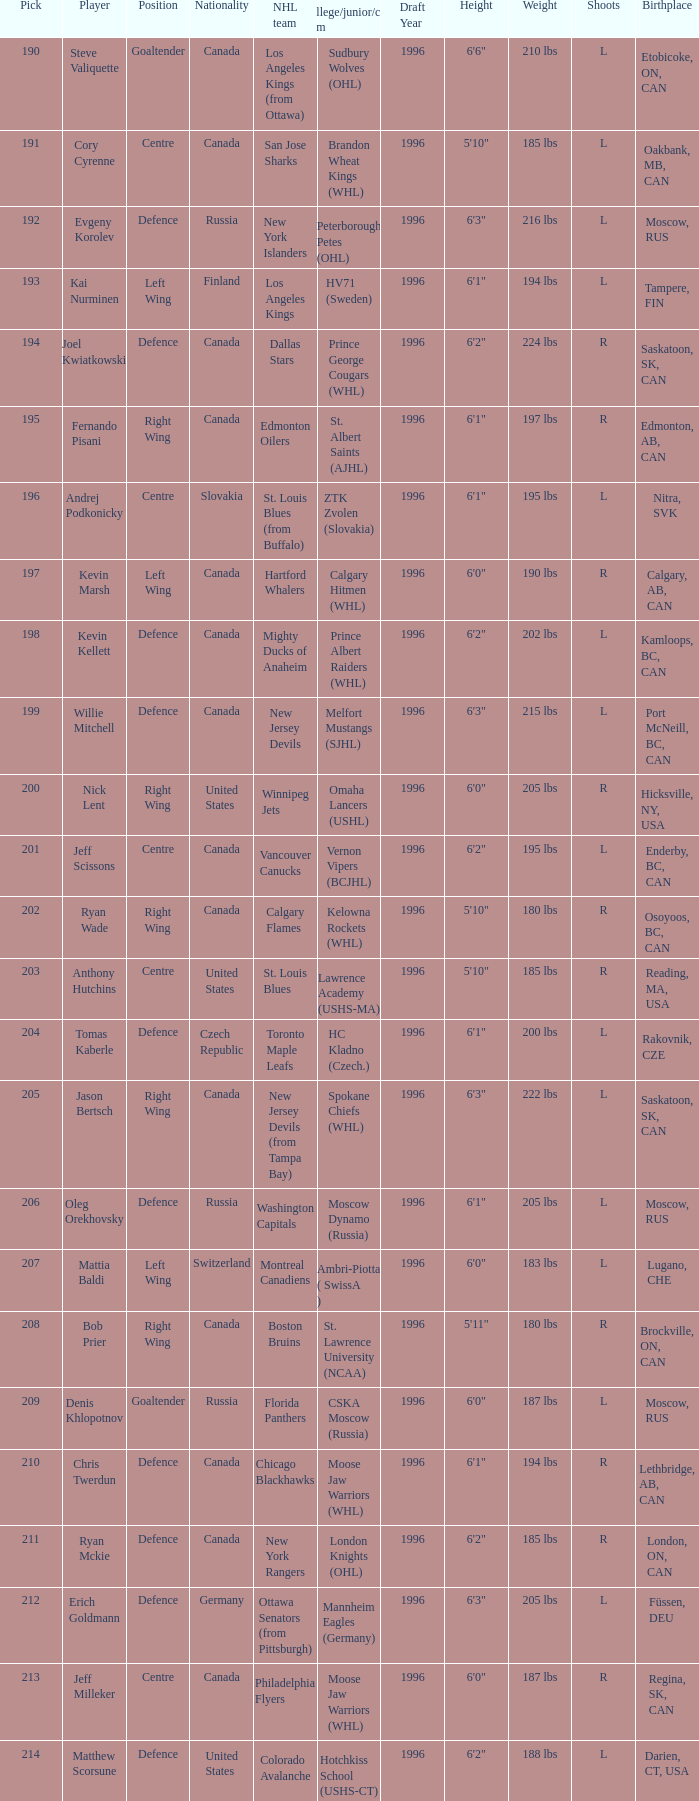Name the college for andrej podkonicky ZTK Zvolen (Slovakia). Write the full table. {'header': ['Pick', 'Player', 'Position', 'Nationality', 'NHL team', 'College/junior/club team', 'Draft Year', 'Height', 'Weight', 'Shoots', 'Birthplace'], 'rows': [['190', 'Steve Valiquette', 'Goaltender', 'Canada', 'Los Angeles Kings (from Ottawa)', 'Sudbury Wolves (OHL)', '1996', '6\'6"', '210 lbs', 'L', 'Etobicoke, ON, CAN'], ['191', 'Cory Cyrenne', 'Centre', 'Canada', 'San Jose Sharks', 'Brandon Wheat Kings (WHL)', '1996', '5\'10"', '185 lbs', 'L', 'Oakbank, MB, CAN'], ['192', 'Evgeny Korolev', 'Defence', 'Russia', 'New York Islanders', 'Peterborough Petes (OHL)', '1996', '6\'3"', '216 lbs', 'L', 'Moscow, RUS'], ['193', 'Kai Nurminen', 'Left Wing', 'Finland', 'Los Angeles Kings', 'HV71 (Sweden)', '1996', '6\'1"', '194 lbs', 'L', 'Tampere, FIN'], ['194', 'Joel Kwiatkowski', 'Defence', 'Canada', 'Dallas Stars', 'Prince George Cougars (WHL)', '1996', '6\'2"', '224 lbs', 'R', 'Saskatoon, SK, CAN'], ['195', 'Fernando Pisani', 'Right Wing', 'Canada', 'Edmonton Oilers', 'St. Albert Saints (AJHL)', '1996', '6\'1"', '197 lbs', 'R', 'Edmonton, AB, CAN'], ['196', 'Andrej Podkonicky', 'Centre', 'Slovakia', 'St. Louis Blues (from Buffalo)', 'ZTK Zvolen (Slovakia)', '1996', '6\'1"', '195 lbs', 'L', 'Nitra, SVK'], ['197', 'Kevin Marsh', 'Left Wing', 'Canada', 'Hartford Whalers', 'Calgary Hitmen (WHL)', '1996', '6\'0"', '190 lbs', 'R', 'Calgary, AB, CAN'], ['198', 'Kevin Kellett', 'Defence', 'Canada', 'Mighty Ducks of Anaheim', 'Prince Albert Raiders (WHL)', '1996', '6\'2"', '202 lbs', 'L', 'Kamloops, BC, CAN'], ['199', 'Willie Mitchell', 'Defence', 'Canada', 'New Jersey Devils', 'Melfort Mustangs (SJHL)', '1996', '6\'3"', '215 lbs', 'L', 'Port McNeill, BC, CAN'], ['200', 'Nick Lent', 'Right Wing', 'United States', 'Winnipeg Jets', 'Omaha Lancers (USHL)', '1996', '6\'0"', '205 lbs', 'R', 'Hicksville, NY, USA'], ['201', 'Jeff Scissons', 'Centre', 'Canada', 'Vancouver Canucks', 'Vernon Vipers (BCJHL)', '1996', '6\'2"', '195 lbs', 'L', 'Enderby, BC, CAN'], ['202', 'Ryan Wade', 'Right Wing', 'Canada', 'Calgary Flames', 'Kelowna Rockets (WHL)', '1996', '5\'10"', '180 lbs', 'R', 'Osoyoos, BC, CAN'], ['203', 'Anthony Hutchins', 'Centre', 'United States', 'St. Louis Blues', 'Lawrence Academy (USHS-MA)', '1996', '5\'10"', '185 lbs', 'R', 'Reading, MA, USA'], ['204', 'Tomas Kaberle', 'Defence', 'Czech Republic', 'Toronto Maple Leafs', 'HC Kladno (Czech.)', '1996', '6\'1"', '200 lbs', 'L', 'Rakovnik, CZE'], ['205', 'Jason Bertsch', 'Right Wing', 'Canada', 'New Jersey Devils (from Tampa Bay)', 'Spokane Chiefs (WHL)', '1996', '6\'3"', '222 lbs', 'L', 'Saskatoon, SK, CAN'], ['206', 'Oleg Orekhovsky', 'Defence', 'Russia', 'Washington Capitals', 'Moscow Dynamo (Russia)', '1996', '6\'1"', '205 lbs', 'L', 'Moscow, RUS'], ['207', 'Mattia Baldi', 'Left Wing', 'Switzerland', 'Montreal Canadiens', 'Ambri-Piotta ( SwissA )', '1996', '6\'0"', '183 lbs', 'L', 'Lugano, CHE'], ['208', 'Bob Prier', 'Right Wing', 'Canada', 'Boston Bruins', 'St. Lawrence University (NCAA)', '1996', '5\'11"', '180 lbs', 'R', 'Brockville, ON, CAN'], ['209', 'Denis Khlopotnov', 'Goaltender', 'Russia', 'Florida Panthers', 'CSKA Moscow (Russia)', '1996', '6\'0"', '187 lbs', 'L', 'Moscow, RUS'], ['210', 'Chris Twerdun', 'Defence', 'Canada', 'Chicago Blackhawks', 'Moose Jaw Warriors (WHL)', '1996', '6\'1"', '194 lbs', 'R', 'Lethbridge, AB, CAN'], ['211', 'Ryan Mckie', 'Defence', 'Canada', 'New York Rangers', 'London Knights (OHL)', '1996', '6\'2"', '185 lbs', 'R', 'London, ON, CAN'], ['212', 'Erich Goldmann', 'Defence', 'Germany', 'Ottawa Senators (from Pittsburgh)', 'Mannheim Eagles (Germany)', '1996', '6\'3"', '205 lbs', 'L', 'Füssen, DEU'], ['213', 'Jeff Milleker', 'Centre', 'Canada', 'Philadelphia Flyers', 'Moose Jaw Warriors (WHL)', '1996', '6\'0"', '187 lbs', 'R', 'Regina, SK, CAN'], ['214', 'Matthew Scorsune', 'Defence', 'United States', 'Colorado Avalanche', 'Hotchkiss School (USHS-CT)', '1996', '6\'2"', '188 lbs', 'L', 'Darien, CT, USA']]} 